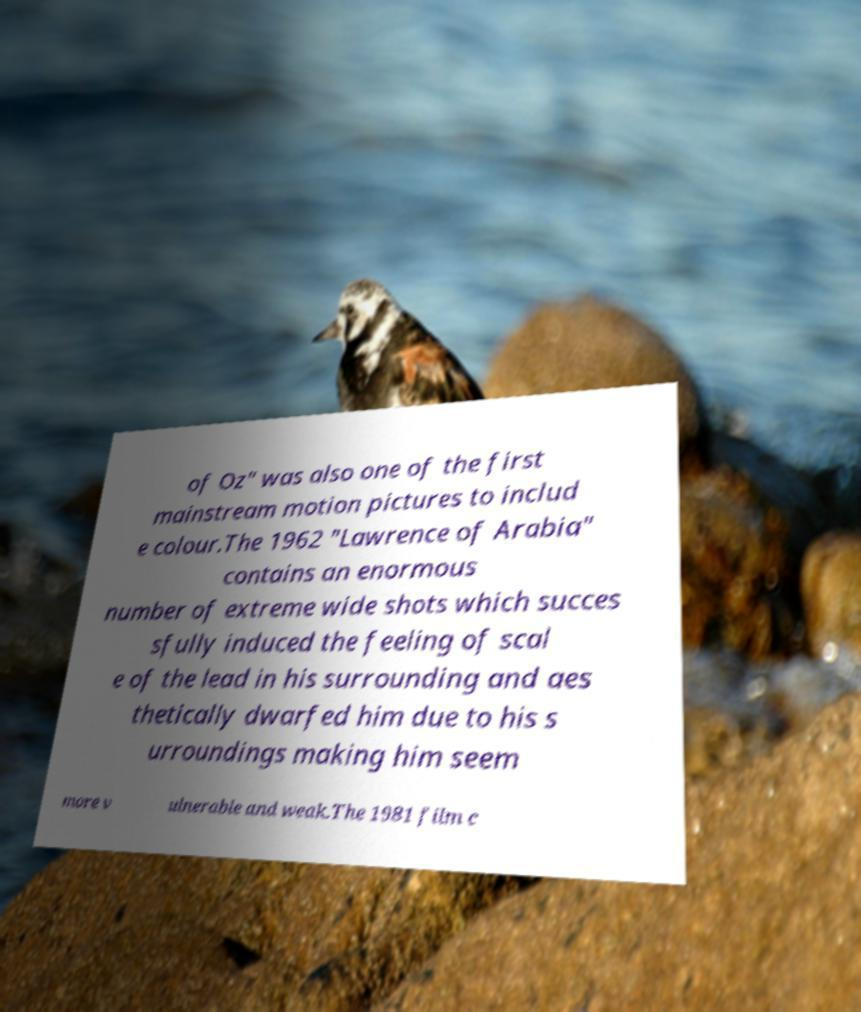Can you accurately transcribe the text from the provided image for me? of Oz" was also one of the first mainstream motion pictures to includ e colour.The 1962 "Lawrence of Arabia" contains an enormous number of extreme wide shots which succes sfully induced the feeling of scal e of the lead in his surrounding and aes thetically dwarfed him due to his s urroundings making him seem more v ulnerable and weak.The 1981 film c 